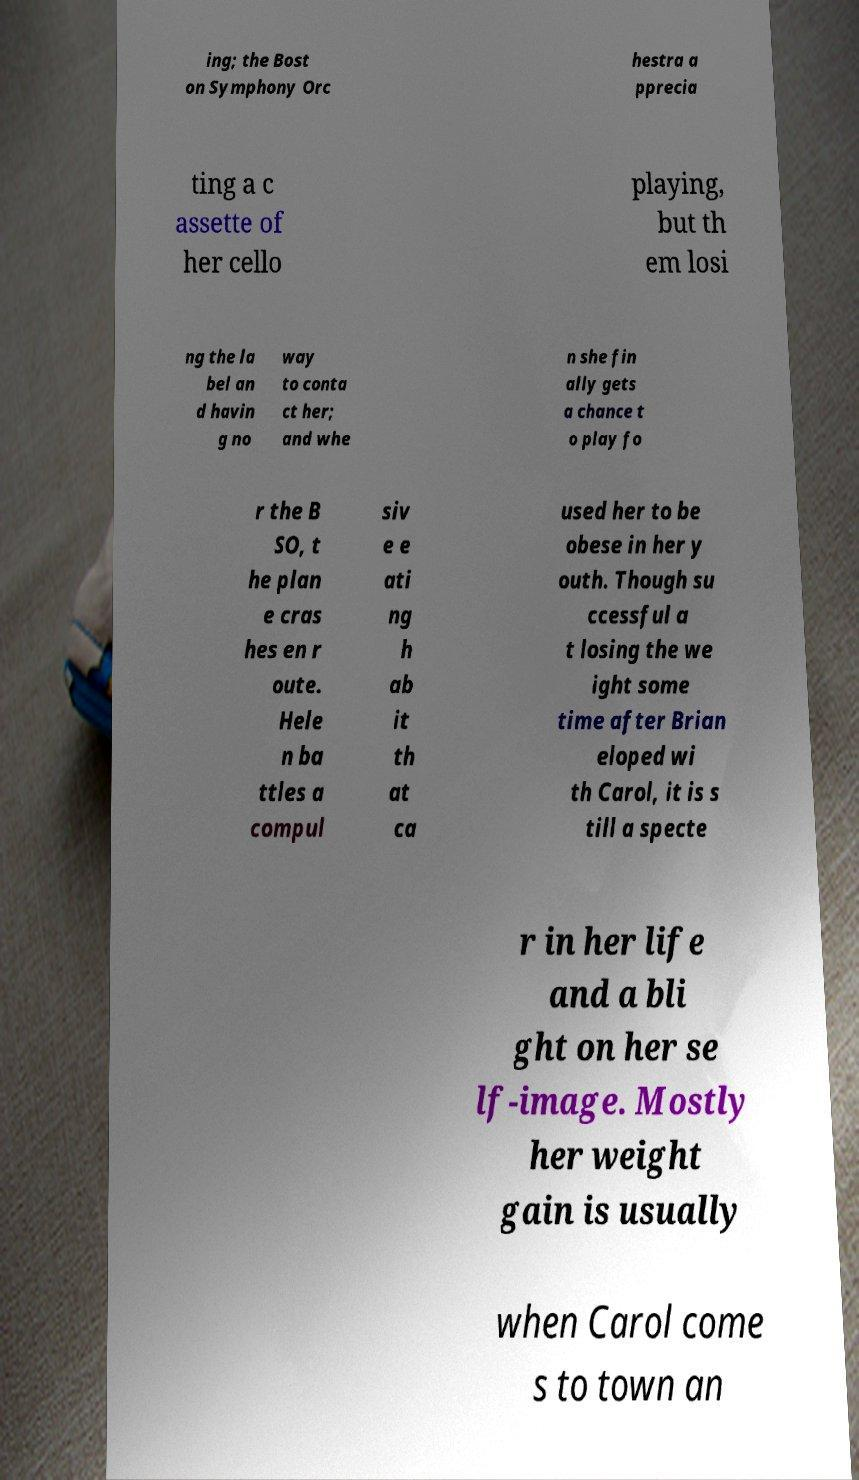There's text embedded in this image that I need extracted. Can you transcribe it verbatim? ing; the Bost on Symphony Orc hestra a pprecia ting a c assette of her cello playing, but th em losi ng the la bel an d havin g no way to conta ct her; and whe n she fin ally gets a chance t o play fo r the B SO, t he plan e cras hes en r oute. Hele n ba ttles a compul siv e e ati ng h ab it th at ca used her to be obese in her y outh. Though su ccessful a t losing the we ight some time after Brian eloped wi th Carol, it is s till a specte r in her life and a bli ght on her se lf-image. Mostly her weight gain is usually when Carol come s to town an 